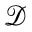Convert formula to latex. <formula><loc_0><loc_0><loc_500><loc_500>\mathcal { D }</formula> 